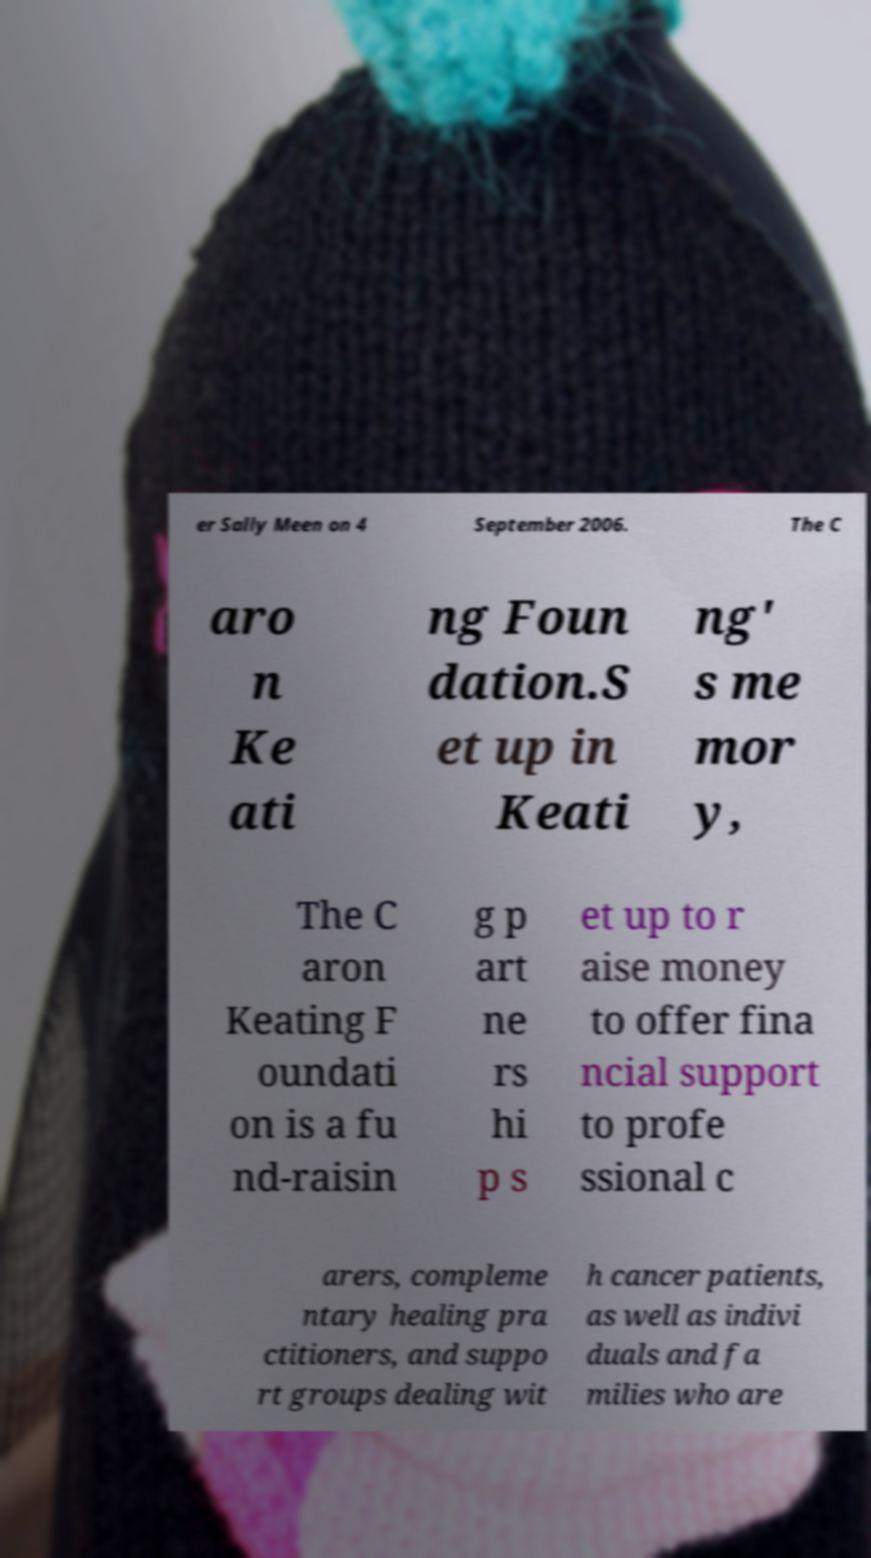Can you read and provide the text displayed in the image?This photo seems to have some interesting text. Can you extract and type it out for me? er Sally Meen on 4 September 2006. The C aro n Ke ati ng Foun dation.S et up in Keati ng' s me mor y, The C aron Keating F oundati on is a fu nd-raisin g p art ne rs hi p s et up to r aise money to offer fina ncial support to profe ssional c arers, compleme ntary healing pra ctitioners, and suppo rt groups dealing wit h cancer patients, as well as indivi duals and fa milies who are 